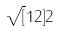<formula> <loc_0><loc_0><loc_500><loc_500>\sqrt { [ } 1 2 ] { 2 }</formula> 